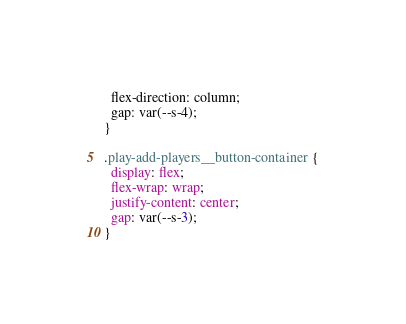<code> <loc_0><loc_0><loc_500><loc_500><_CSS_>  flex-direction: column;
  gap: var(--s-4);
}

.play-add-players__button-container {
  display: flex;
  flex-wrap: wrap;
  justify-content: center;
  gap: var(--s-3);
}
</code> 